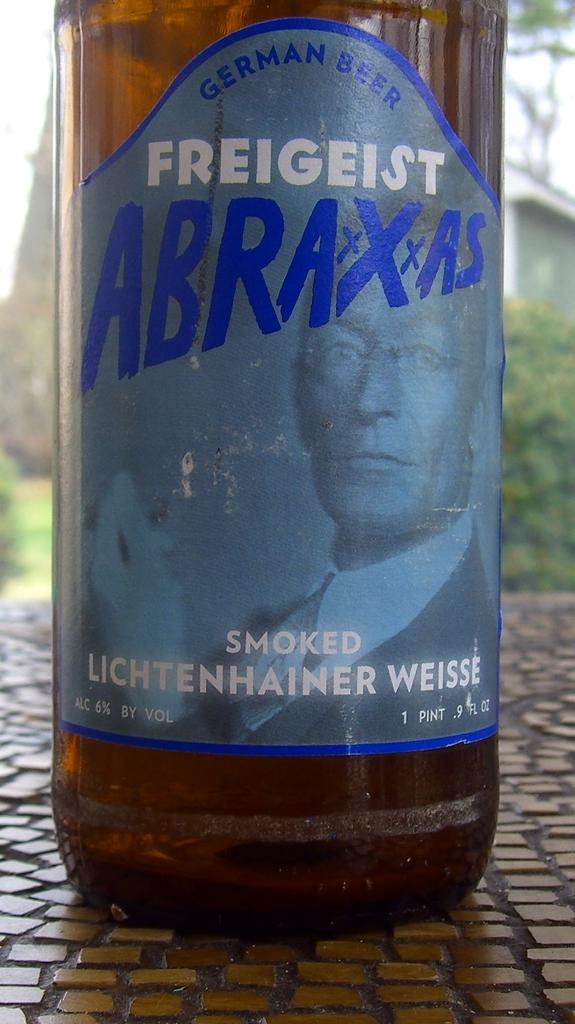What is located in the foreground of the image? There is a bottle in the foreground of the image. What can be seen on the bottle? There is text on the bottle. What is visible at the bottom of the image? There is a floor at the bottom of the image. What type of structures can be seen in the background of the image? There are houses in the background of the image. What type of vegetation is visible in the background of the image? There are trees in the background of the image. Can you see any yaks grazing on the coast in the image? There are no yaks or coast visible in the image; it features a bottle with text, a floor, houses, and trees in the background. 